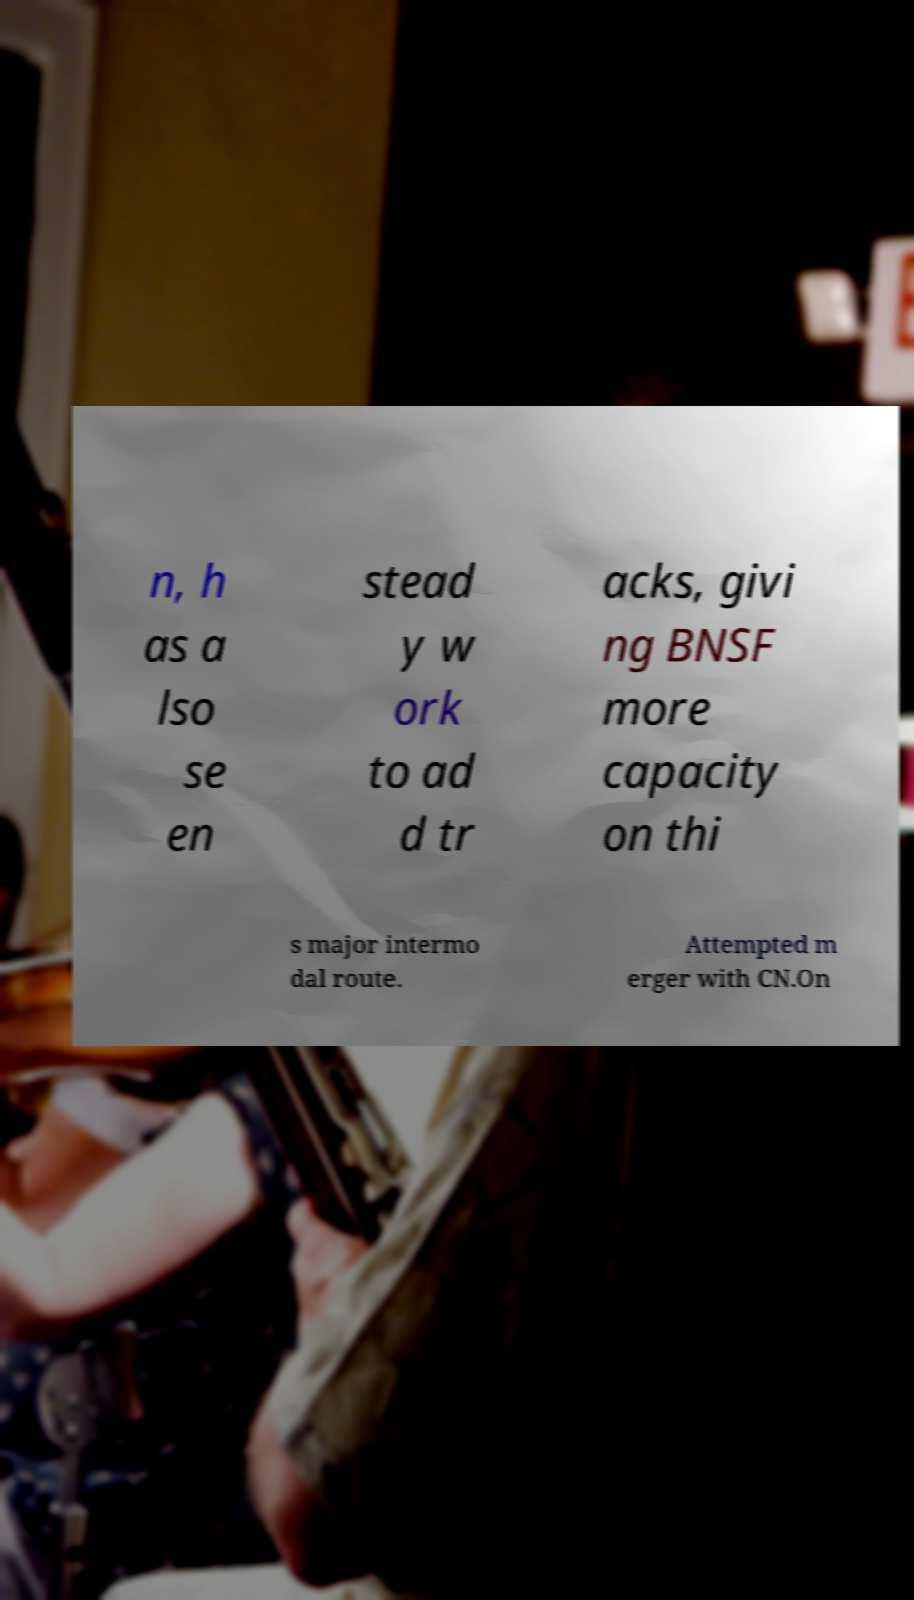What messages or text are displayed in this image? I need them in a readable, typed format. n, h as a lso se en stead y w ork to ad d tr acks, givi ng BNSF more capacity on thi s major intermo dal route. Attempted m erger with CN.On 